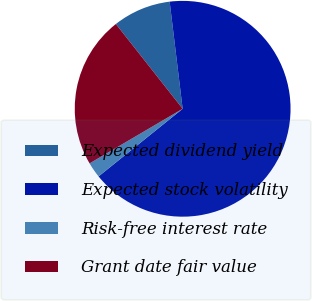<chart> <loc_0><loc_0><loc_500><loc_500><pie_chart><fcel>Expected dividend yield<fcel>Expected stock volatility<fcel>Risk-free interest rate<fcel>Grant date fair value<nl><fcel>8.7%<fcel>66.14%<fcel>2.33%<fcel>22.83%<nl></chart> 